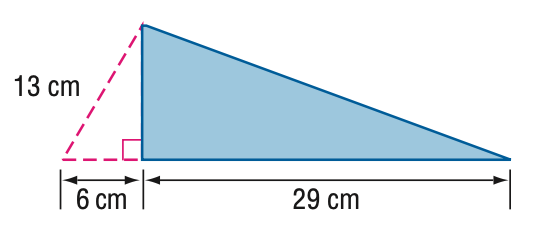Answer the mathemtical geometry problem and directly provide the correct option letter.
Question: Find the perimeter of the triangle.
Choices: A: 40.5 B: 60.2 C: 71.7 D: 75.7 C 